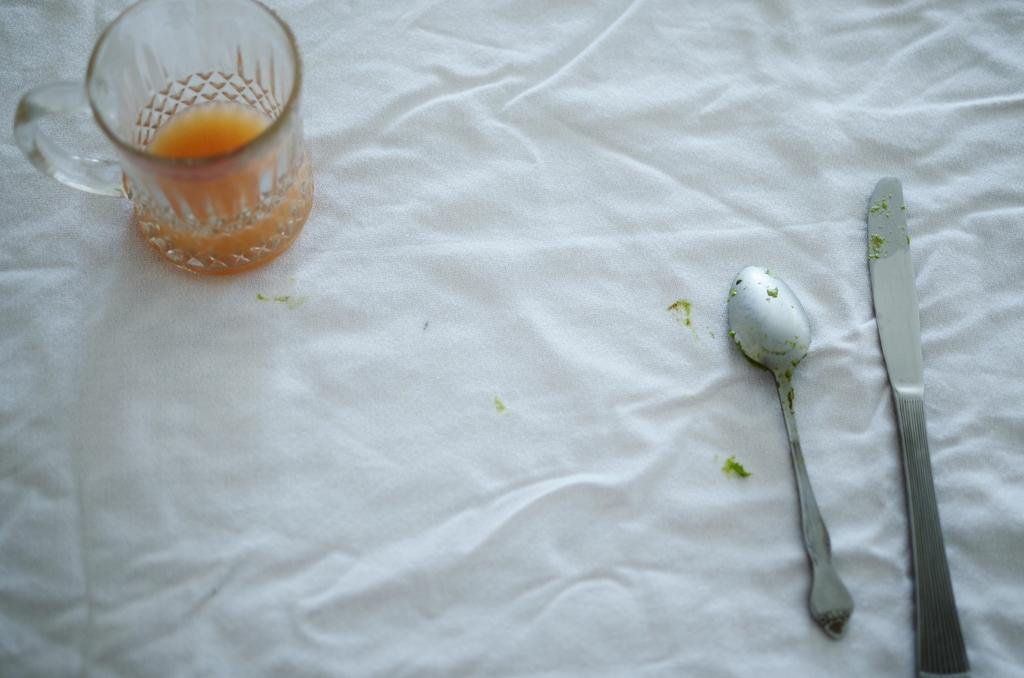What is located in the top left of the image? There is a glass on a cloth in the top left of the image. What utensils can be seen in the bottom right of the image? There is a knife and a spoon on a cloth in the bottom right of the image. What color is the background of the image? The background of the image is white. What type of punishment is being depicted in the image? There is no punishment being depicted in the image; it features a glass, knife, spoon, and cloth on a white background. How does the beginner learn to fight in the image? There is no fighting or learning to fight in the image; it is a simple arrangement of objects on a cloth. 